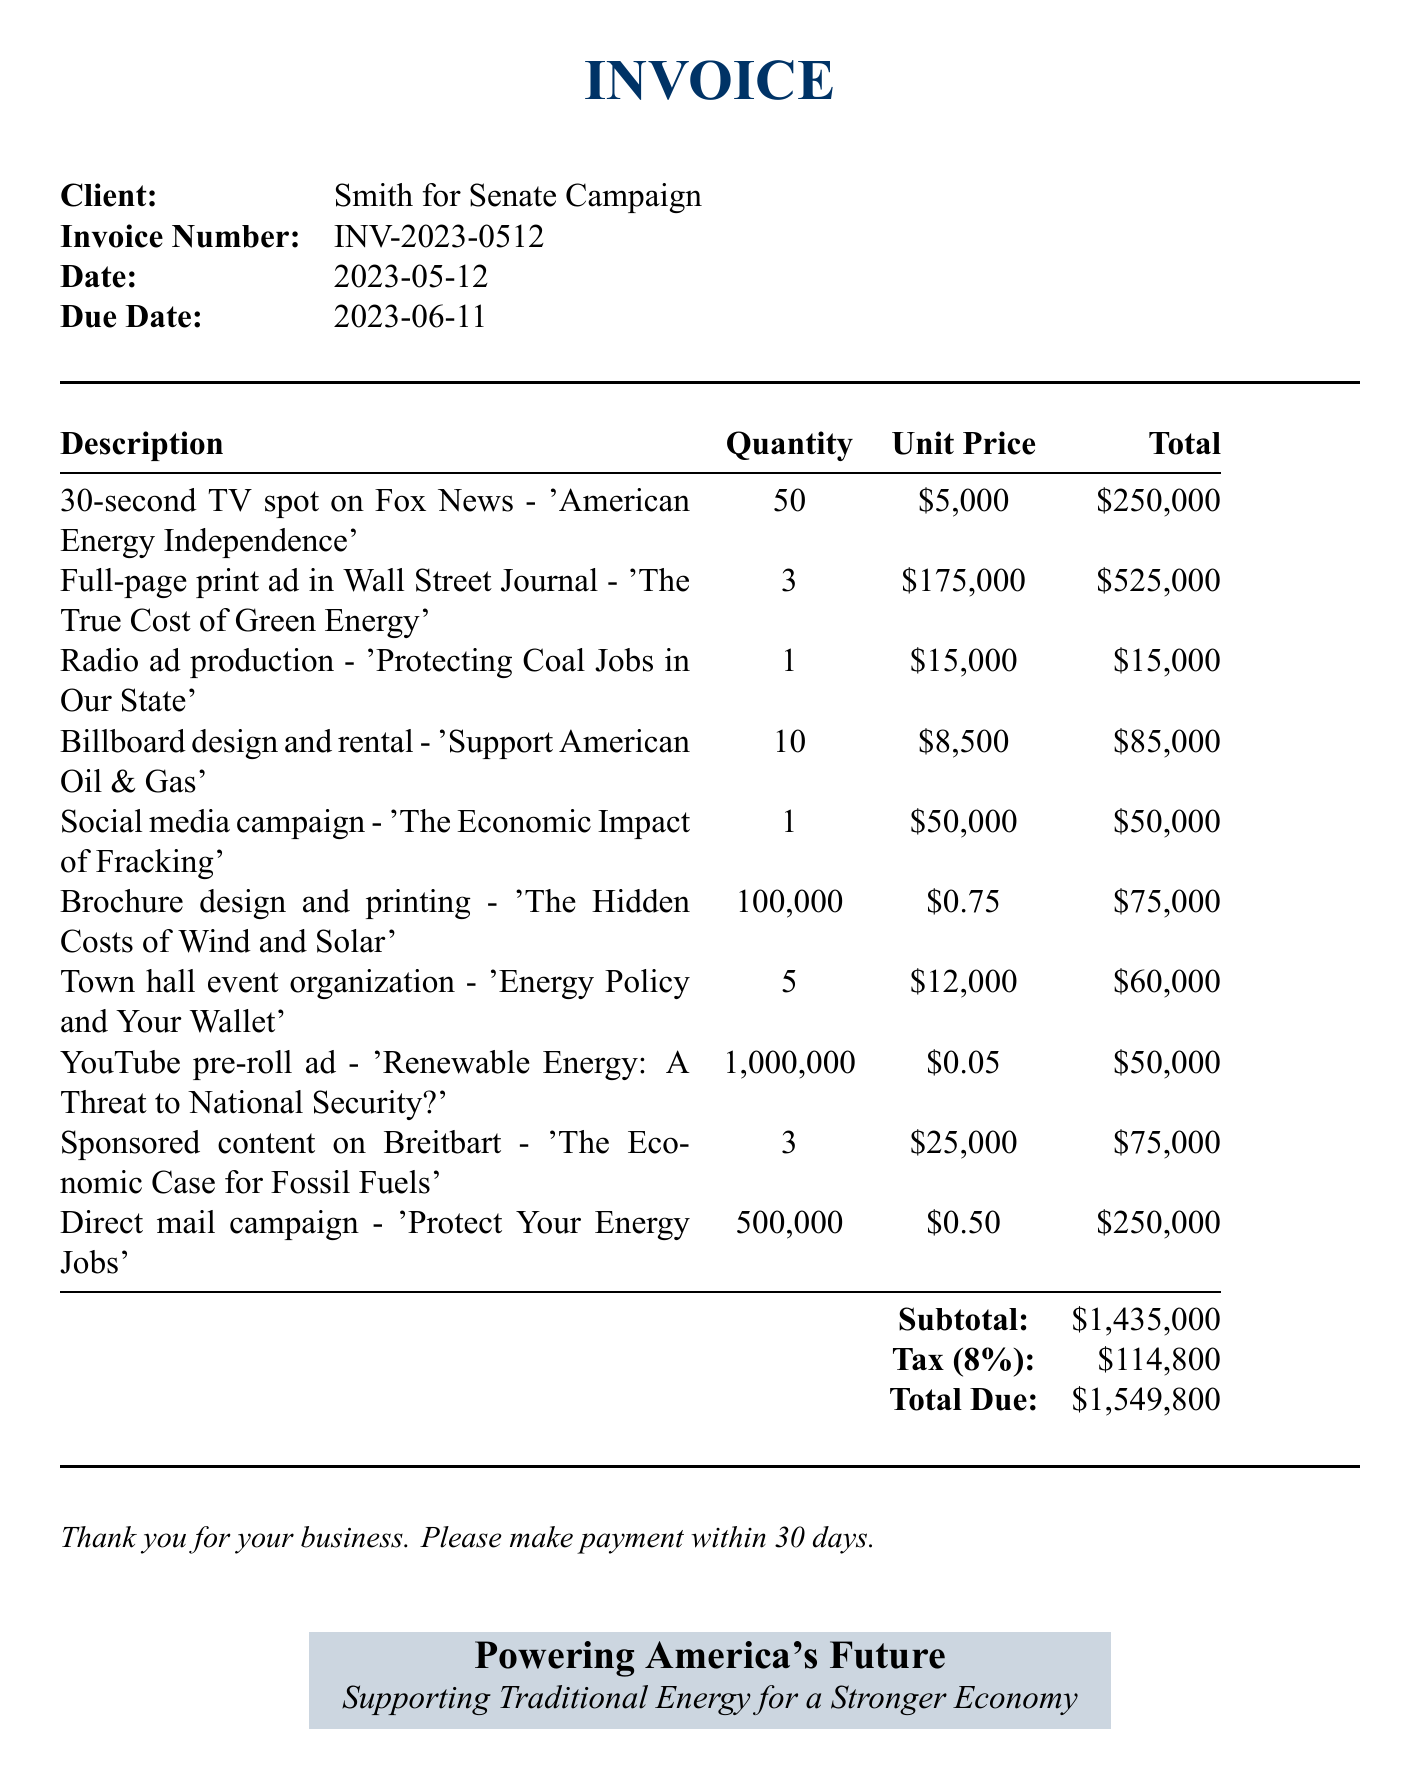What is the client name? The client name is stated at the beginning of the invoice.
Answer: Smith for Senate Campaign What is the invoice number? The invoice number is listed under invoice details.
Answer: INV-2023-0512 What is the total due amount? The total due is calculated at the bottom of the invoice, consisting of the subtotal and tax.
Answer: $1,549,800 How many TV spots were purchased? The quantity of TV spots is found in the line items section under the TV spot description.
Answer: 50 What is the unit price for a full-page print ad? The unit price for the full-page print ad can be found in the corresponding line item.
Answer: $175,000 Which item focuses on protecting coal jobs? This item can be found in the description of the relevant line item.
Answer: Radio ad production What is the subtotal amount? The subtotal is presented in the calculations at the end of the invoice.
Answer: $1,435,000 How many brochures were designed and printed? The quantity for the brochure design appears in the line items section.
Answer: 100,000 What is the tax rate applied? The tax rate is mentioned in the calculations section of the invoice.
Answer: 8% 